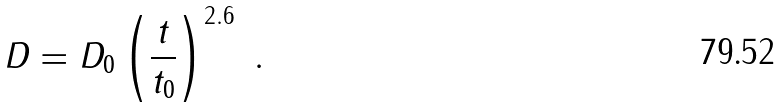<formula> <loc_0><loc_0><loc_500><loc_500>D = D _ { 0 } \left ( \frac { t } { t _ { 0 } } \right ) ^ { 2 . 6 } \ .</formula> 